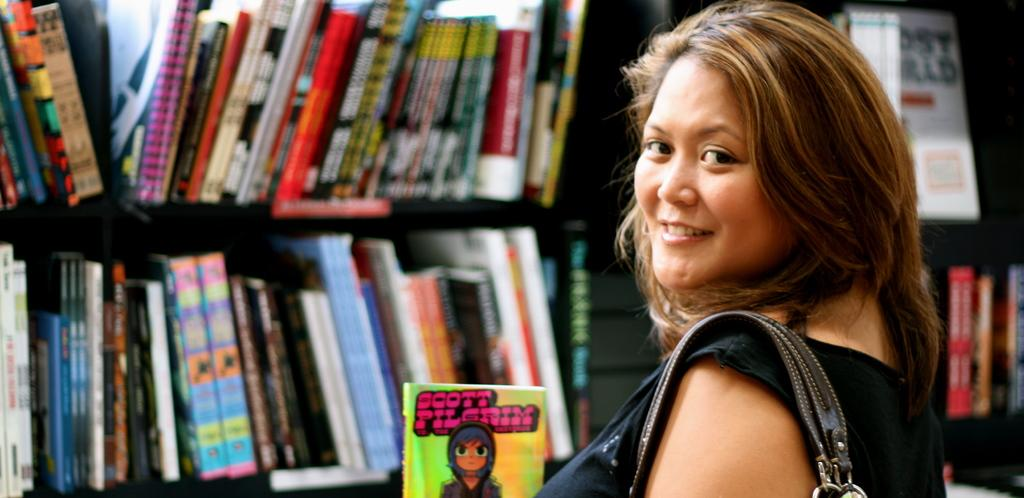<image>
Provide a brief description of the given image. Woman stands in front of bookshelves full of books holding up a Scott Pilgrim book with its front cover facing forward. 